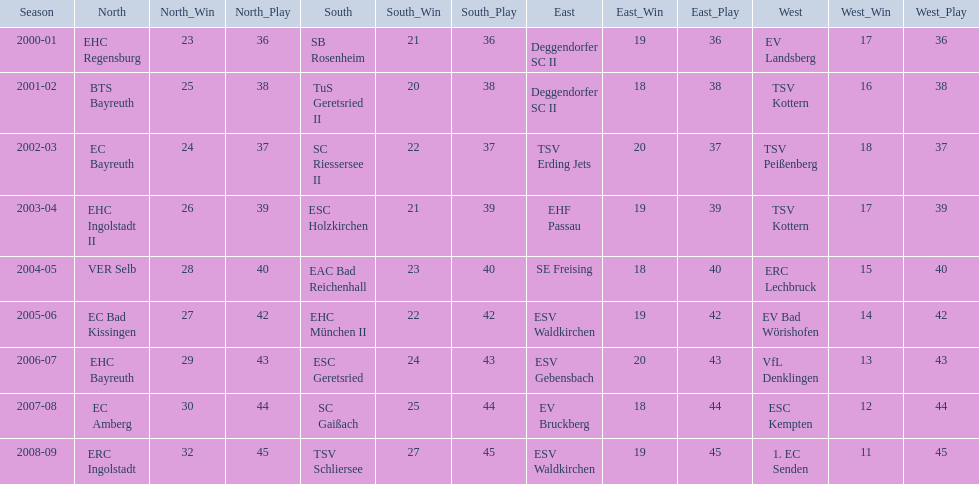What is the number of seasons covered in the table? 9. 